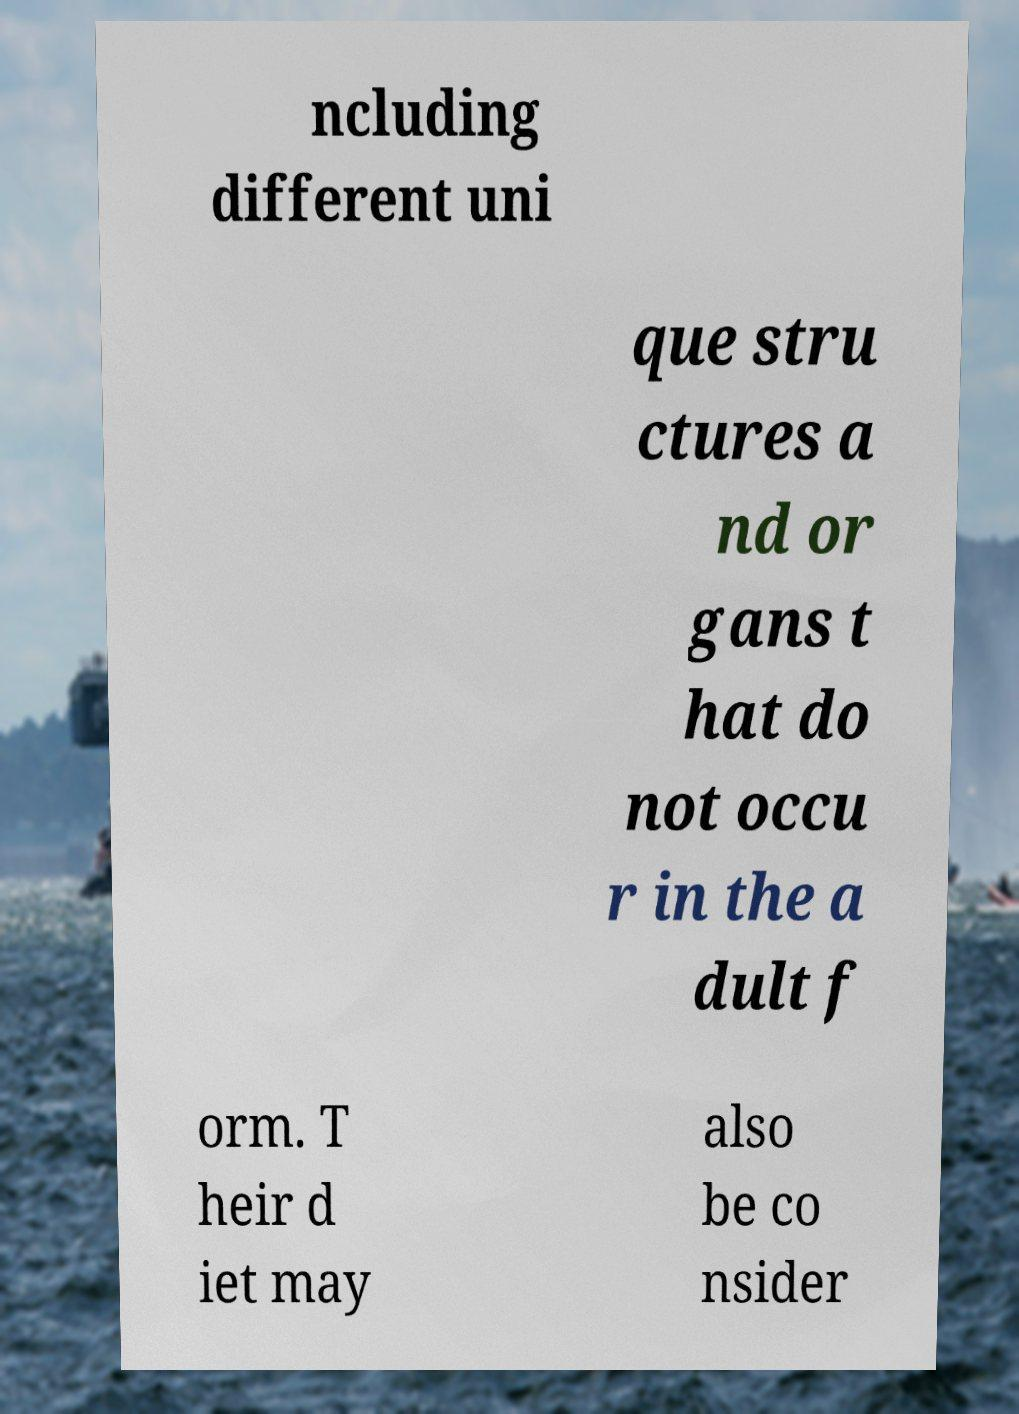What messages or text are displayed in this image? I need them in a readable, typed format. ncluding different uni que stru ctures a nd or gans t hat do not occu r in the a dult f orm. T heir d iet may also be co nsider 